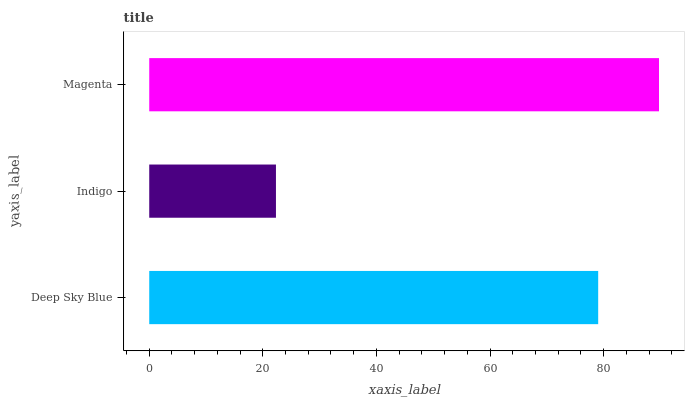Is Indigo the minimum?
Answer yes or no. Yes. Is Magenta the maximum?
Answer yes or no. Yes. Is Magenta the minimum?
Answer yes or no. No. Is Indigo the maximum?
Answer yes or no. No. Is Magenta greater than Indigo?
Answer yes or no. Yes. Is Indigo less than Magenta?
Answer yes or no. Yes. Is Indigo greater than Magenta?
Answer yes or no. No. Is Magenta less than Indigo?
Answer yes or no. No. Is Deep Sky Blue the high median?
Answer yes or no. Yes. Is Deep Sky Blue the low median?
Answer yes or no. Yes. Is Magenta the high median?
Answer yes or no. No. Is Magenta the low median?
Answer yes or no. No. 